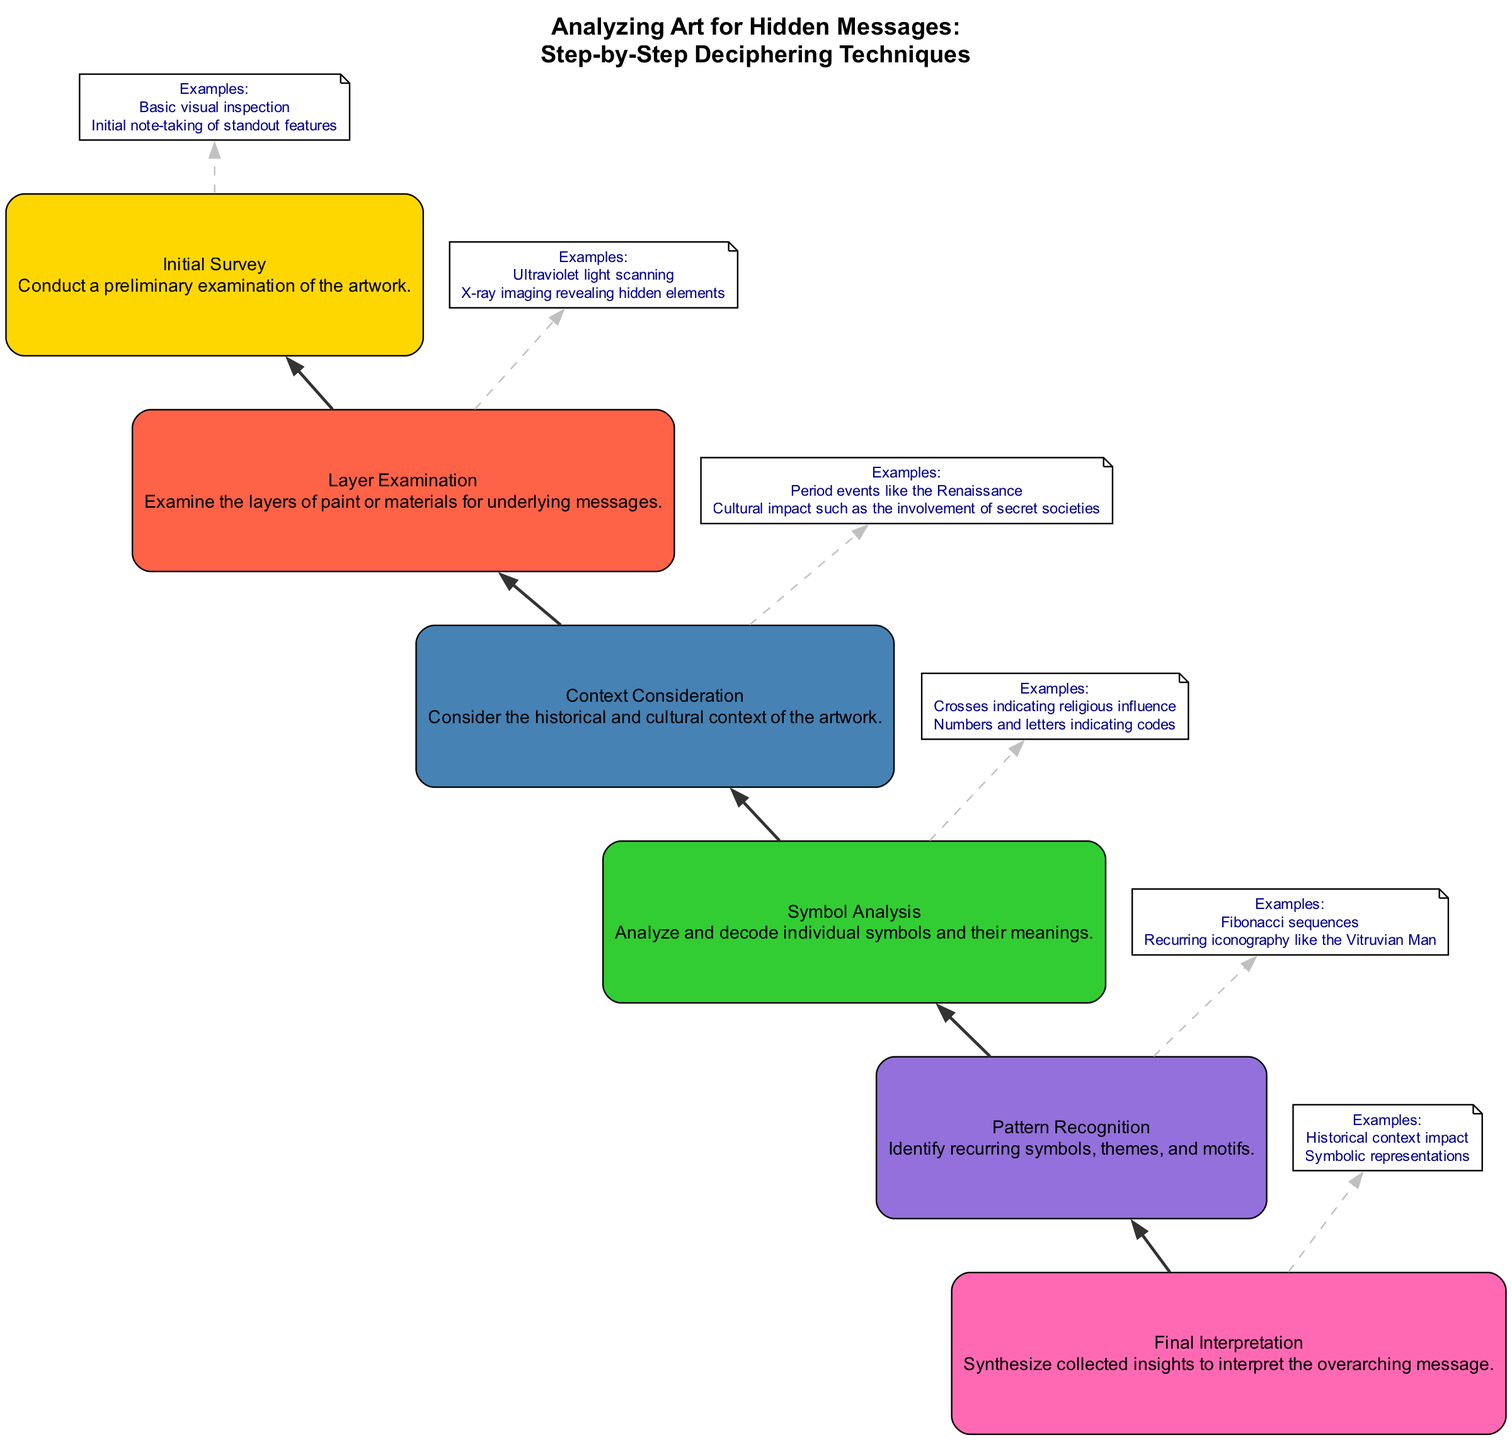What is the final step in the diagram? The final step in the diagram is labeled "Final Interpretation," which synthesizes collected insights.
Answer: Final Interpretation How many steps are present in the diagram? The diagram contains a total of 6 steps, from Initial Survey to Final Interpretation.
Answer: 6 What is one example provided under "Symbol Analysis"? One example under "Symbol Analysis" is "Crosses indicating religious influence."
Answer: Crosses indicating religious influence What connects "Layer Examination" and "Context Consideration"? "Layer Examination" connects to "Context Consideration" through a direct edge indicating the flow of the deciphering process.
Answer: A direct edge What is the main purpose of "Pattern Recognition"? The purpose of "Pattern Recognition" is to identify recurring symbols, themes, and motifs within the artwork.
Answer: Identify recurring symbols, themes, and motifs Which step comes immediately before "Final Interpretation"? The step that comes immediately before "Final Interpretation" is "Symbol Analysis," as the flow moves upward in the diagram.
Answer: Symbol Analysis What type of connection style is used between each step? The connection style used between each step is a solid edge, indicating a direct flow from one step to the next.
Answer: Solid edge What is a technique mentioned in "Layer Examination"? One technique mentioned in "Layer Examination" is "Ultraviolet light scanning."
Answer: Ultraviolet light scanning Which example relates to "Context Consideration"? An example that relates to "Context Consideration" is "Period events like the Renaissance."
Answer: Period events like the Renaissance 